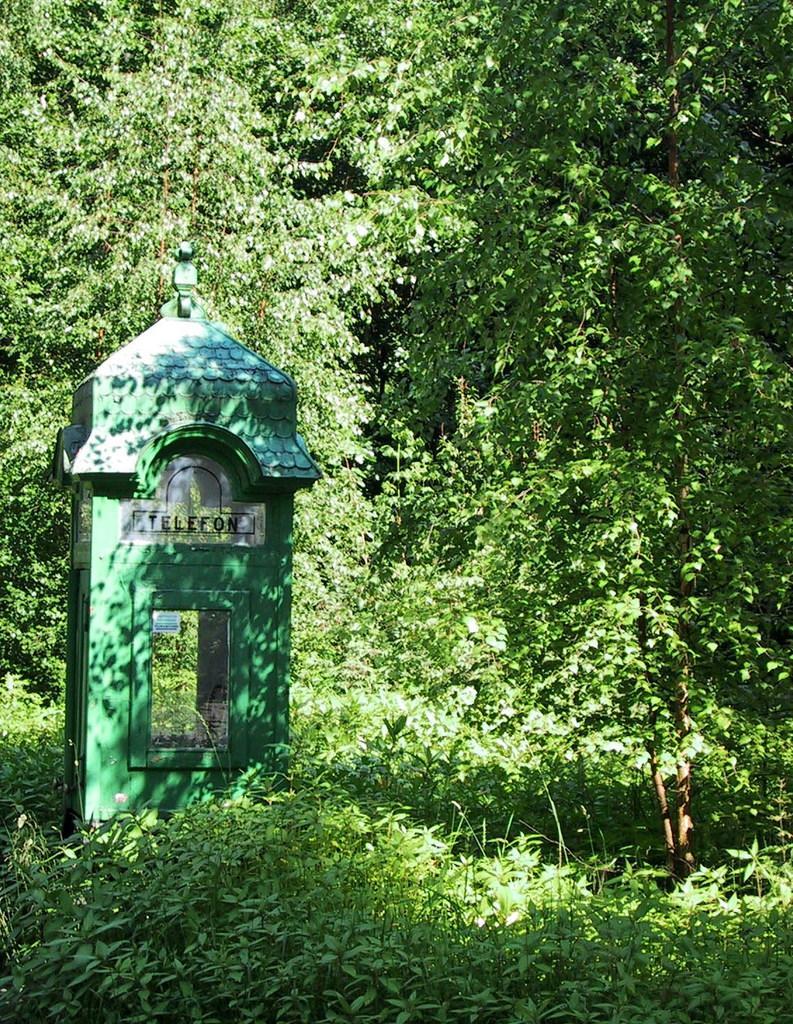Please provide a concise description of this image. In this image, we can see so many trees and plants. On the left side of the image, we can see a telephone booth. Here we can see a glass and sticker. 